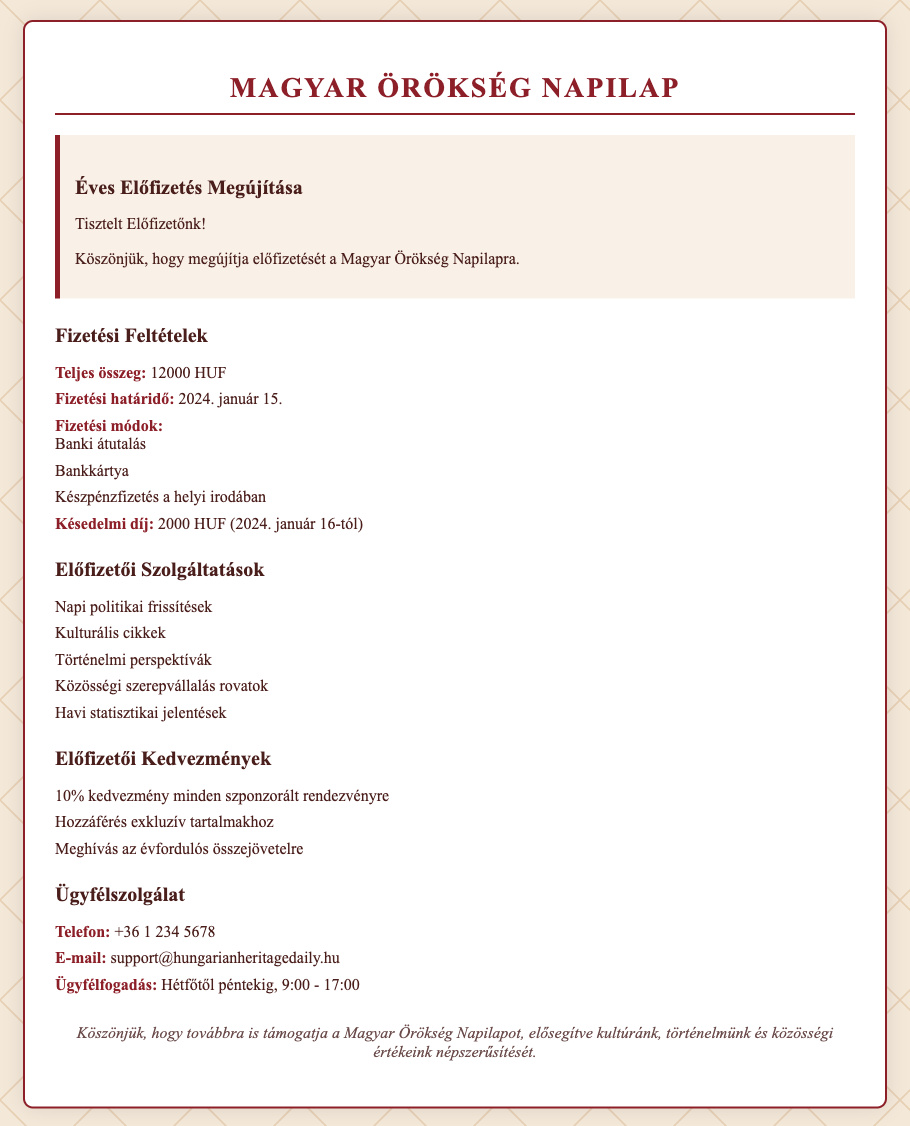what is the total subscription fee? The total subscription fee mentioned in the document is stated clearly under payment terms.
Answer: 12000 HUF when is the payment deadline? The payment deadline is specified in the payment terms section of the document.
Answer: 2024. január 15 what penalty is applied after the payment deadline? The document states the penalty applied for late payment explicitly.
Answer: 2000 HUF what payment methods are available? The document lists the acceptable payment methods under the payment terms.
Answer: Banki átutalás, Bankkártya, Készpénzfizetés a helyi irodában what type of updates can subscribers receive daily? This information can be found in the subscriber services section of the document.
Answer: Napi politikai frissítések which discounts do subscribers get? The document outlines specific discounts available to subscribers.
Answer: 10% kedvezmény minden szponzorált rendezvényre what additional services do subscribers receive monthly? The document indicates the monthly service provided to subscribers.
Answer: Havi statisztikai jelentések what is the customer service phone number? The document includes contact information for customer service.
Answer: +36 1 234 5678 what are the customer service hours? The operational hours for customer service are clearly outlined in the document.
Answer: Hétfőtől péntekig, 9:00 - 17:00 